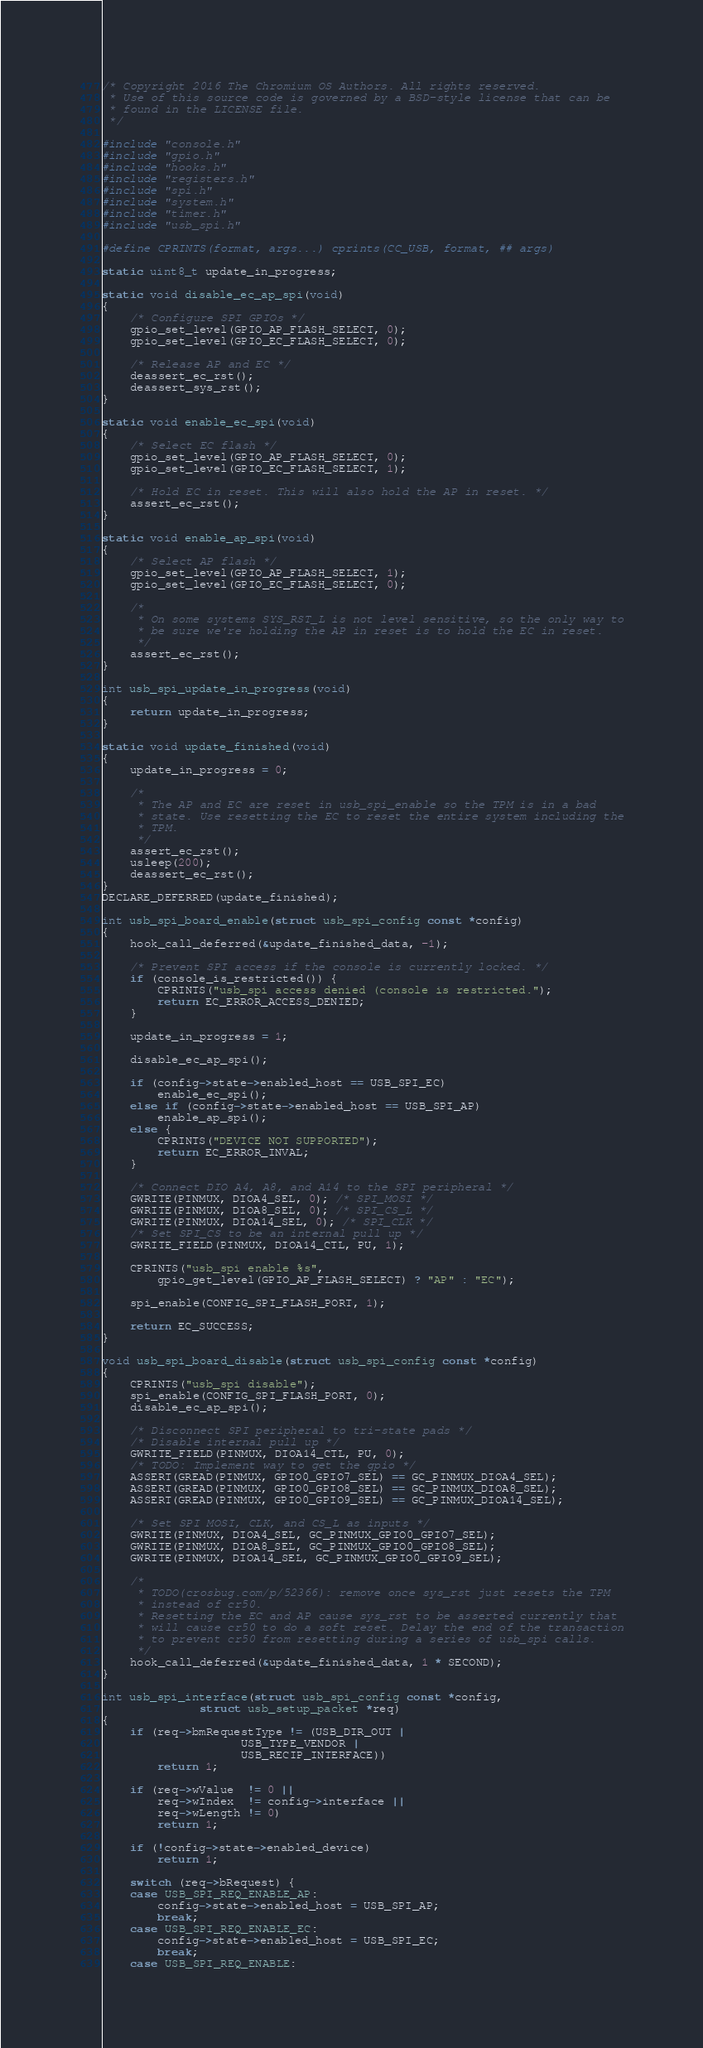<code> <loc_0><loc_0><loc_500><loc_500><_C_>/* Copyright 2016 The Chromium OS Authors. All rights reserved.
 * Use of this source code is governed by a BSD-style license that can be
 * found in the LICENSE file.
 */

#include "console.h"
#include "gpio.h"
#include "hooks.h"
#include "registers.h"
#include "spi.h"
#include "system.h"
#include "timer.h"
#include "usb_spi.h"

#define CPRINTS(format, args...) cprints(CC_USB, format, ## args)

static uint8_t update_in_progress;

static void disable_ec_ap_spi(void)
{
	/* Configure SPI GPIOs */
	gpio_set_level(GPIO_AP_FLASH_SELECT, 0);
	gpio_set_level(GPIO_EC_FLASH_SELECT, 0);

	/* Release AP and EC */
	deassert_ec_rst();
	deassert_sys_rst();
}

static void enable_ec_spi(void)
{
	/* Select EC flash */
	gpio_set_level(GPIO_AP_FLASH_SELECT, 0);
	gpio_set_level(GPIO_EC_FLASH_SELECT, 1);

	/* Hold EC in reset. This will also hold the AP in reset. */
	assert_ec_rst();
}

static void enable_ap_spi(void)
{
	/* Select AP flash */
	gpio_set_level(GPIO_AP_FLASH_SELECT, 1);
	gpio_set_level(GPIO_EC_FLASH_SELECT, 0);

	/*
	 * On some systems SYS_RST_L is not level sensitive, so the only way to
	 * be sure we're holding the AP in reset is to hold the EC in reset.
	 */
	assert_ec_rst();
}

int usb_spi_update_in_progress(void)
{
	return update_in_progress;
}

static void update_finished(void)
{
	update_in_progress = 0;

	/*
	 * The AP and EC are reset in usb_spi_enable so the TPM is in a bad
	 * state. Use resetting the EC to reset the entire system including the
	 * TPM.
	 */
	assert_ec_rst();
	usleep(200);
	deassert_ec_rst();
}
DECLARE_DEFERRED(update_finished);

int usb_spi_board_enable(struct usb_spi_config const *config)
{
	hook_call_deferred(&update_finished_data, -1);

	/* Prevent SPI access if the console is currently locked. */
	if (console_is_restricted()) {
		CPRINTS("usb_spi access denied (console is restricted.");
		return EC_ERROR_ACCESS_DENIED;
	}

	update_in_progress = 1;

	disable_ec_ap_spi();

	if (config->state->enabled_host == USB_SPI_EC)
		enable_ec_spi();
	else if (config->state->enabled_host == USB_SPI_AP)
		enable_ap_spi();
	else {
		CPRINTS("DEVICE NOT SUPPORTED");
		return EC_ERROR_INVAL;
	}

	/* Connect DIO A4, A8, and A14 to the SPI peripheral */
	GWRITE(PINMUX, DIOA4_SEL, 0); /* SPI_MOSI */
	GWRITE(PINMUX, DIOA8_SEL, 0); /* SPI_CS_L */
	GWRITE(PINMUX, DIOA14_SEL, 0); /* SPI_CLK */
	/* Set SPI_CS to be an internal pull up */
	GWRITE_FIELD(PINMUX, DIOA14_CTL, PU, 1);

	CPRINTS("usb_spi enable %s",
		gpio_get_level(GPIO_AP_FLASH_SELECT) ? "AP" : "EC");

	spi_enable(CONFIG_SPI_FLASH_PORT, 1);

	return EC_SUCCESS;
}

void usb_spi_board_disable(struct usb_spi_config const *config)
{
	CPRINTS("usb_spi disable");
	spi_enable(CONFIG_SPI_FLASH_PORT, 0);
	disable_ec_ap_spi();

	/* Disconnect SPI peripheral to tri-state pads */
	/* Disable internal pull up */
	GWRITE_FIELD(PINMUX, DIOA14_CTL, PU, 0);
	/* TODO: Implement way to get the gpio */
	ASSERT(GREAD(PINMUX, GPIO0_GPIO7_SEL) == GC_PINMUX_DIOA4_SEL);
	ASSERT(GREAD(PINMUX, GPIO0_GPIO8_SEL) == GC_PINMUX_DIOA8_SEL);
	ASSERT(GREAD(PINMUX, GPIO0_GPIO9_SEL) == GC_PINMUX_DIOA14_SEL);

	/* Set SPI MOSI, CLK, and CS_L as inputs */
	GWRITE(PINMUX, DIOA4_SEL, GC_PINMUX_GPIO0_GPIO7_SEL);
	GWRITE(PINMUX, DIOA8_SEL, GC_PINMUX_GPIO0_GPIO8_SEL);
	GWRITE(PINMUX, DIOA14_SEL, GC_PINMUX_GPIO0_GPIO9_SEL);

	/*
	 * TODO(crosbug.com/p/52366): remove once sys_rst just resets the TPM
	 * instead of cr50.
	 * Resetting the EC and AP cause sys_rst to be asserted currently that
	 * will cause cr50 to do a soft reset. Delay the end of the transaction
	 * to prevent cr50 from resetting during a series of usb_spi calls.
	 */
	hook_call_deferred(&update_finished_data, 1 * SECOND);
}

int usb_spi_interface(struct usb_spi_config const *config,
		      struct usb_setup_packet *req)
{
	if (req->bmRequestType != (USB_DIR_OUT |
				    USB_TYPE_VENDOR |
				    USB_RECIP_INTERFACE))
		return 1;

	if (req->wValue  != 0 ||
	    req->wIndex  != config->interface ||
	    req->wLength != 0)
		return 1;

	if (!config->state->enabled_device)
		return 1;

	switch (req->bRequest) {
	case USB_SPI_REQ_ENABLE_AP:
		config->state->enabled_host = USB_SPI_AP;
		break;
	case USB_SPI_REQ_ENABLE_EC:
		config->state->enabled_host = USB_SPI_EC;
		break;
	case USB_SPI_REQ_ENABLE:</code> 